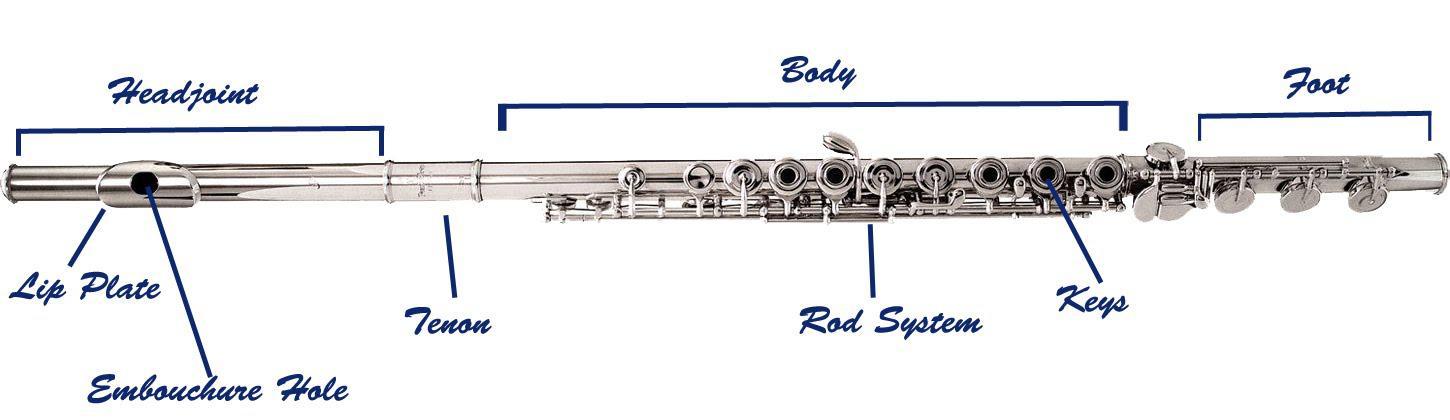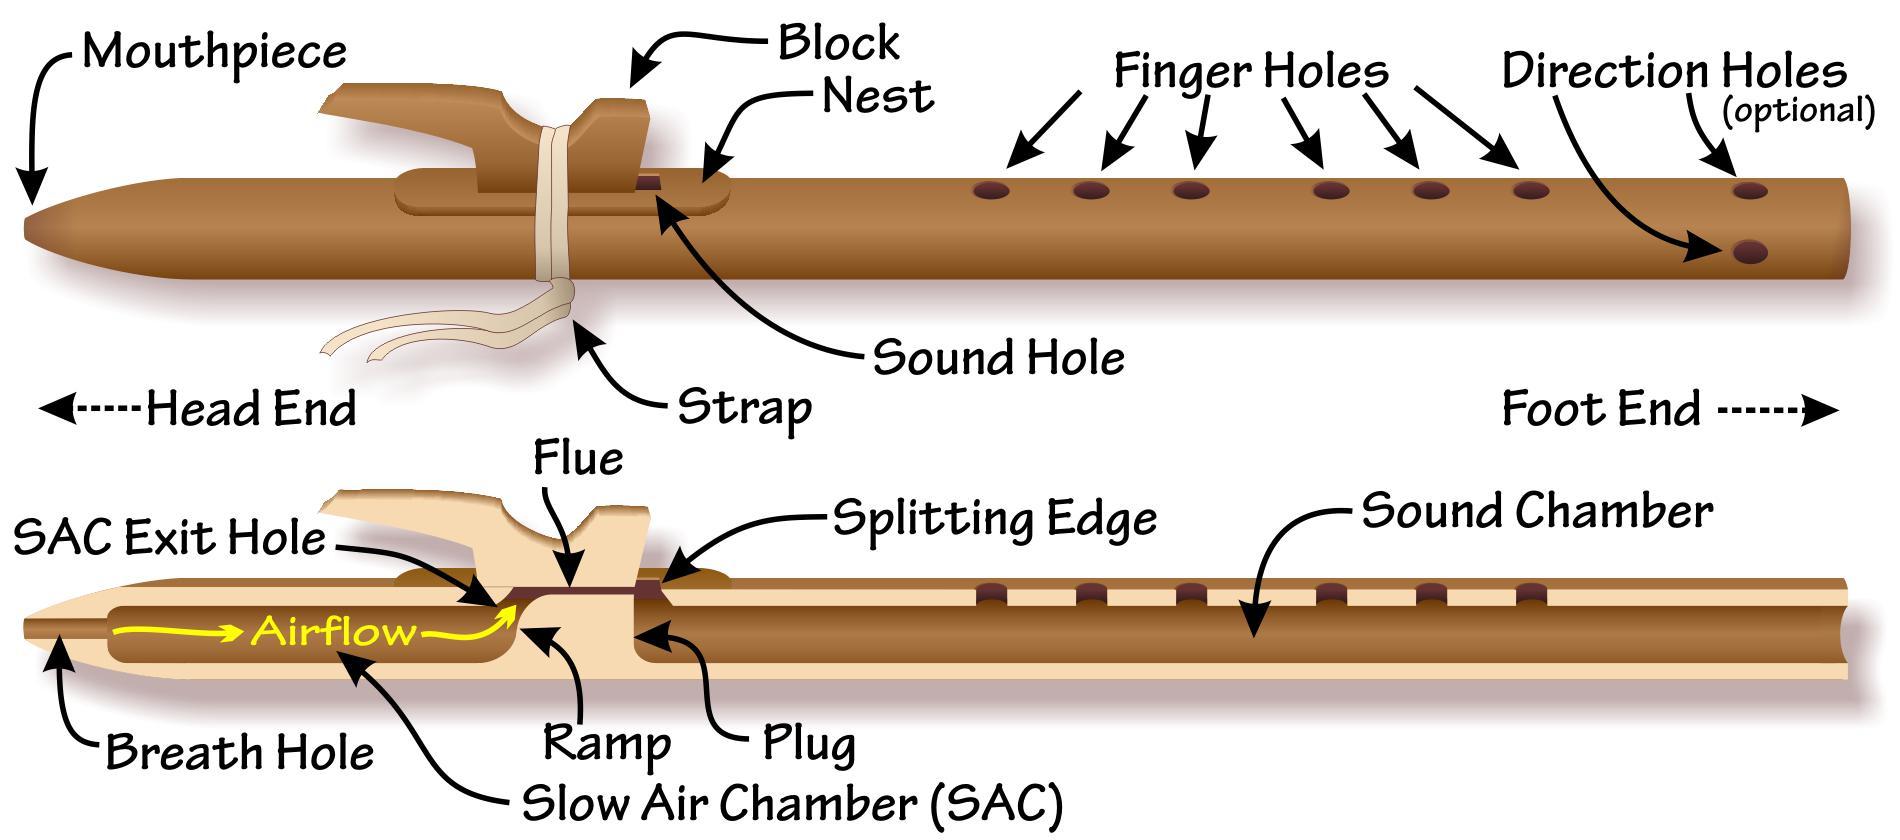The first image is the image on the left, the second image is the image on the right. Assess this claim about the two images: "There are two flute illustrations in the right image.". Correct or not? Answer yes or no. Yes. 